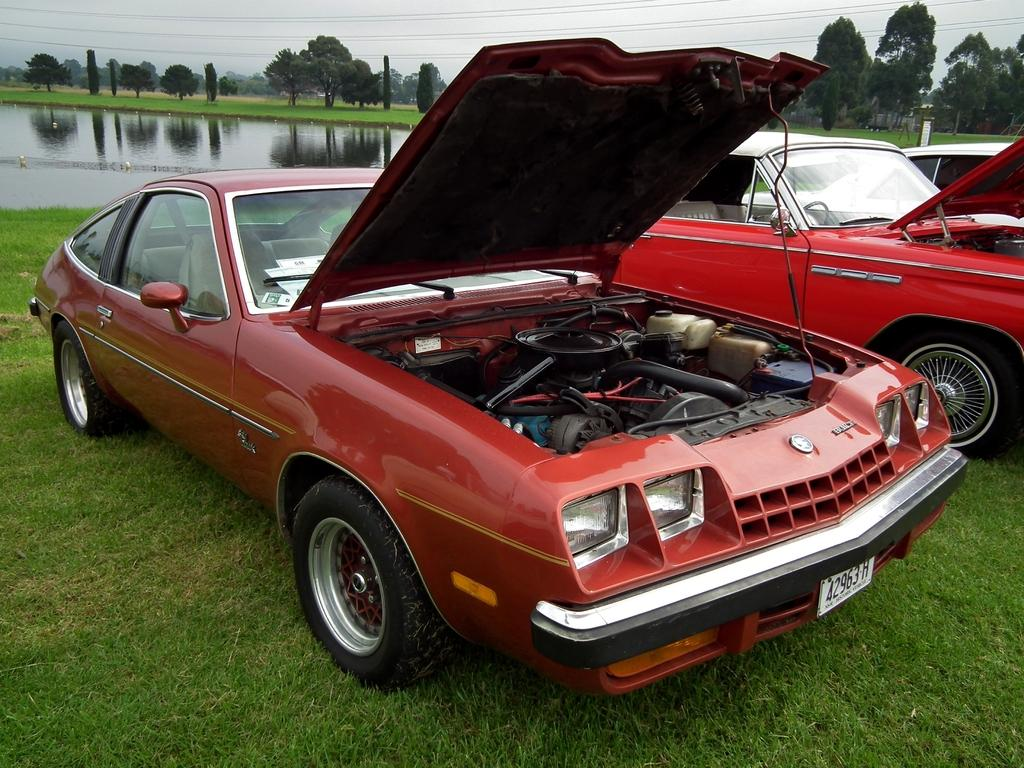What is located on the grass in the image? There are vehicles on the grass in the image. What can be seen in the background of the image? There is water and trees visible in the background of the image. What type of quill is being used to write a fictional story in the image? There is no quill or fictional story present in the image. How many dolls are sitting on the grass in the image? There are no dolls present in the image. 